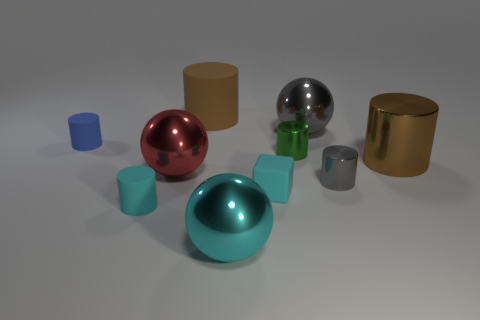Subtract all big shiny cylinders. How many cylinders are left? 5 Subtract all red cubes. How many brown cylinders are left? 2 Subtract 3 cylinders. How many cylinders are left? 3 Subtract all cyan cylinders. How many cylinders are left? 5 Subtract all spheres. How many objects are left? 7 Subtract all tiny objects. Subtract all small cyan things. How many objects are left? 3 Add 1 small metallic cylinders. How many small metallic cylinders are left? 3 Add 8 gray metallic spheres. How many gray metallic spheres exist? 9 Subtract 0 gray blocks. How many objects are left? 10 Subtract all brown cubes. Subtract all gray cylinders. How many cubes are left? 1 